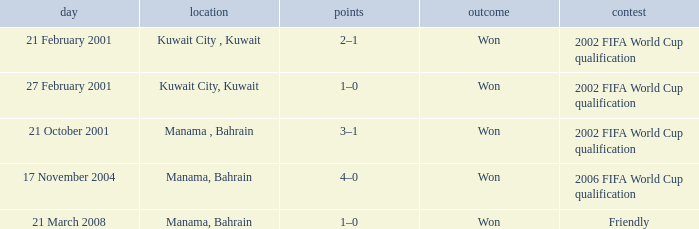On which date was the match in Manama, Bahrain? 21 October 2001, 17 November 2004, 21 March 2008. 